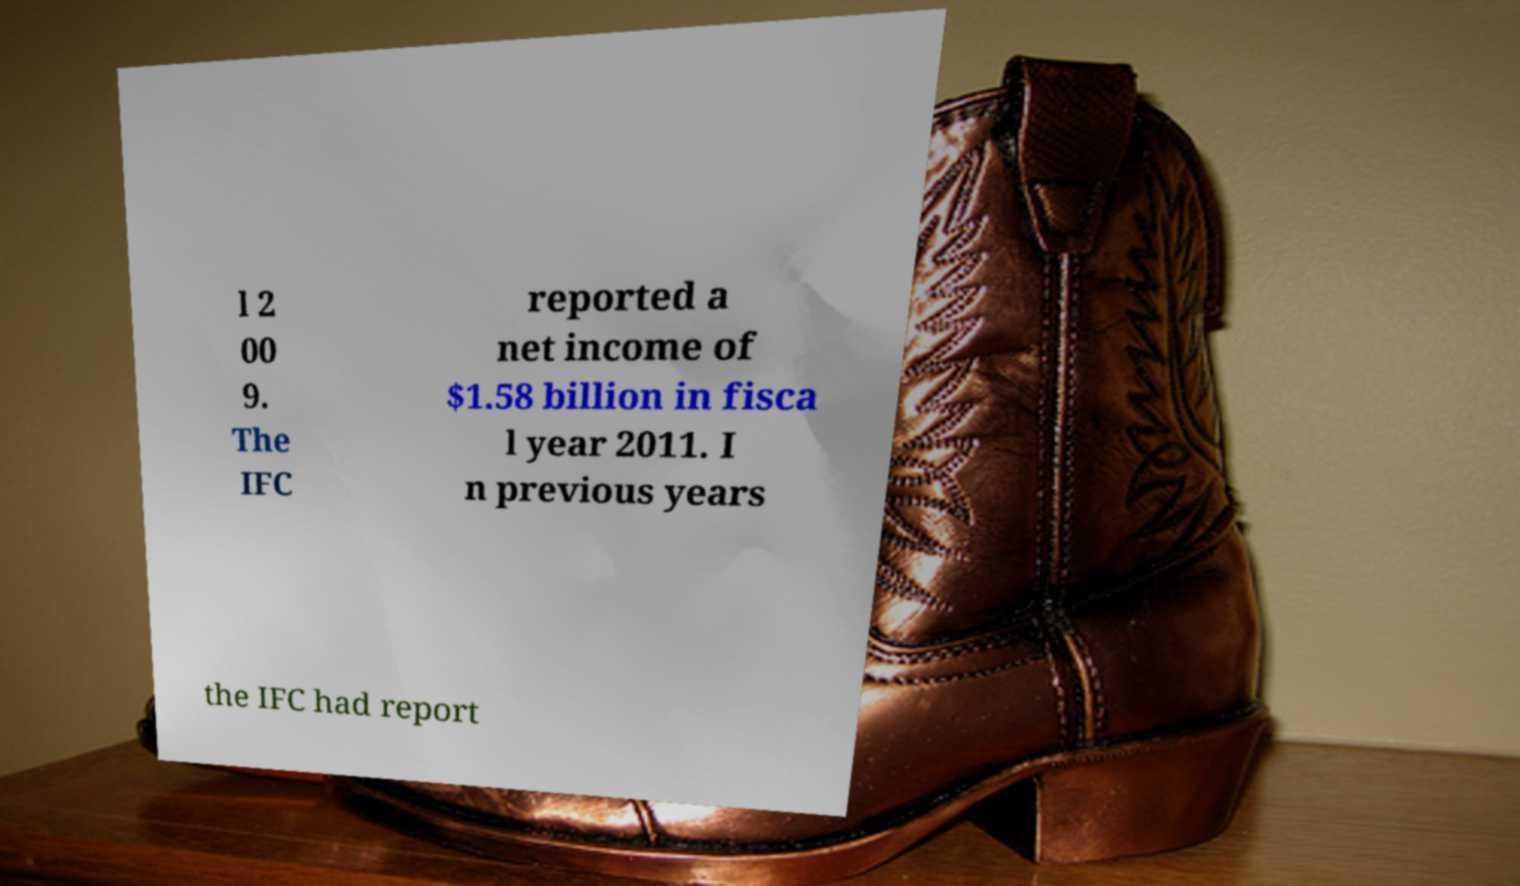Can you accurately transcribe the text from the provided image for me? l 2 00 9. The IFC reported a net income of $1.58 billion in fisca l year 2011. I n previous years the IFC had report 